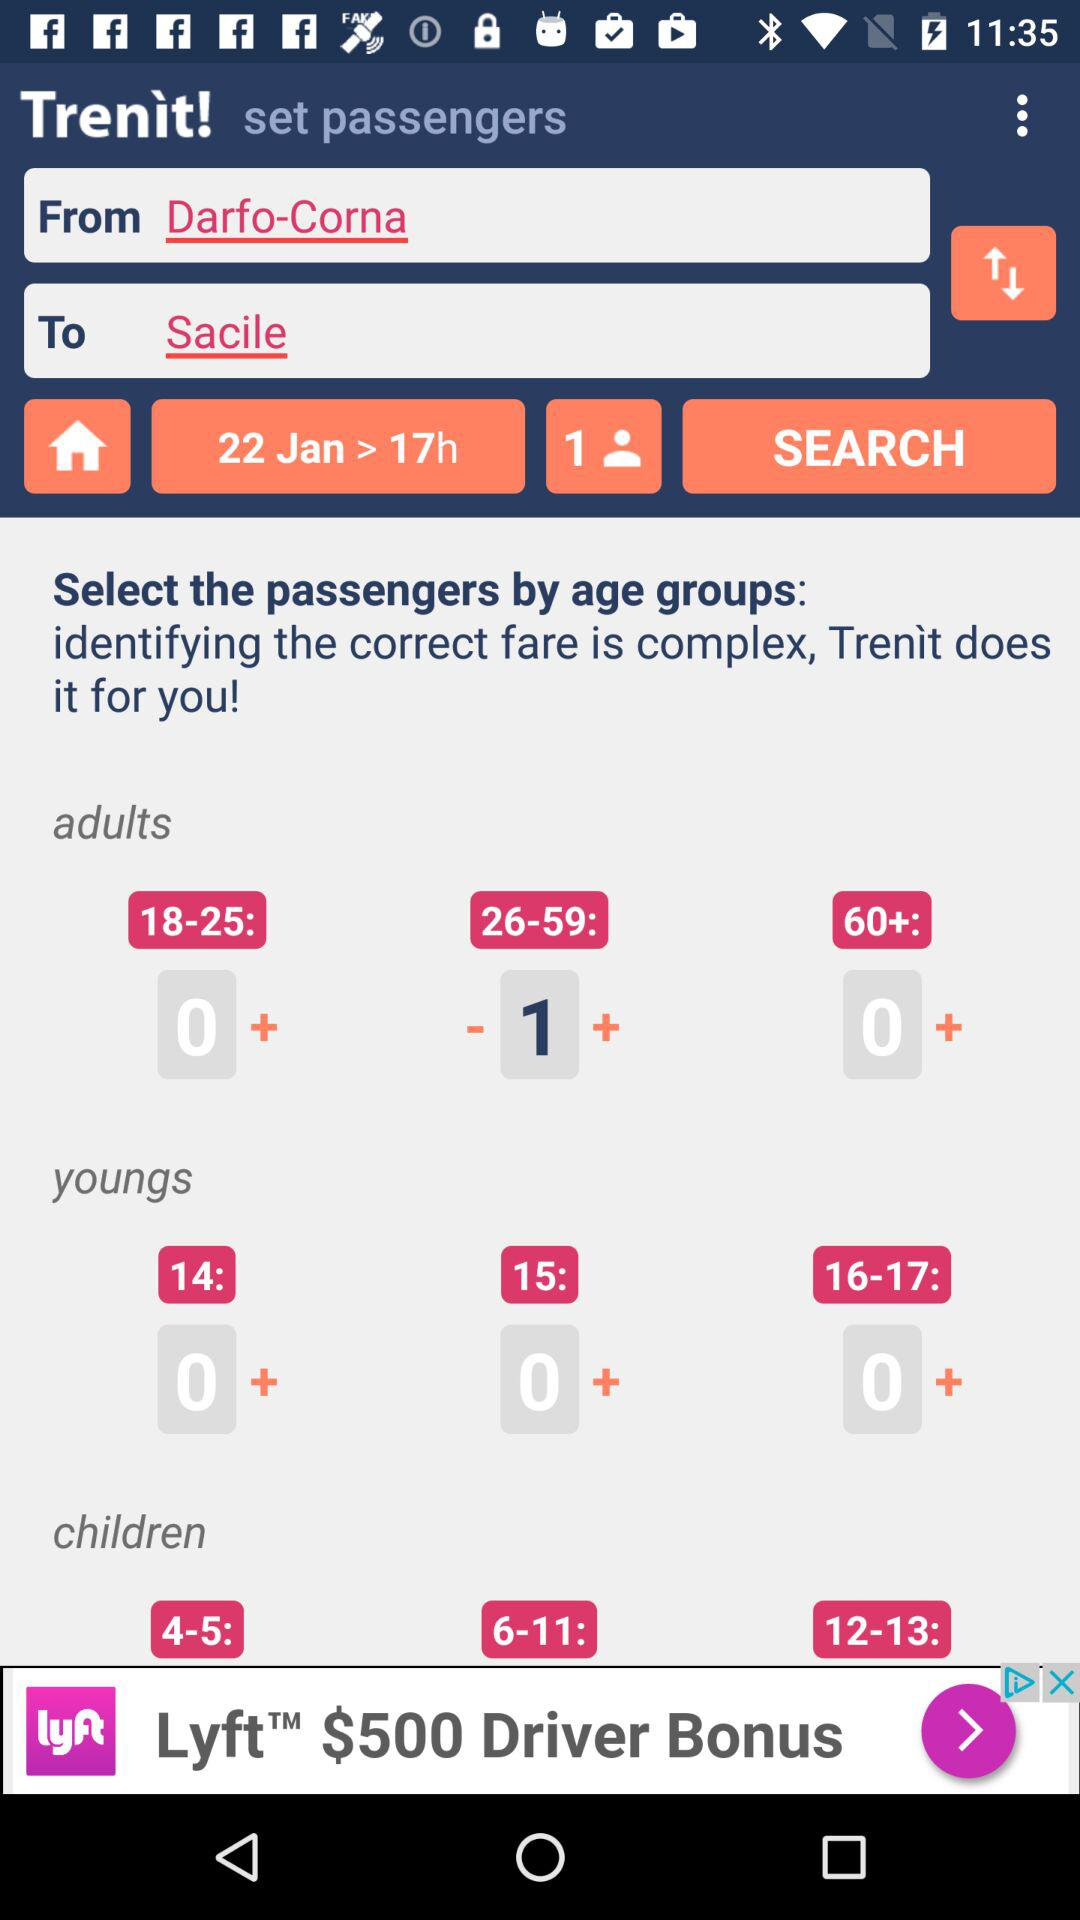What is the total journey distance?
When the provided information is insufficient, respond with <no answer>. <no answer> 